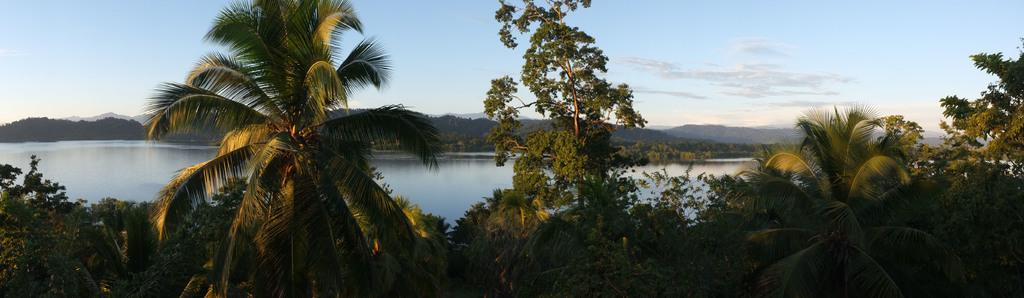What type of vegetation is at the bottom of the image? There are trees at the bottom of the image. What natural feature is visible in the image? There is a surface of water in the image. What geographical feature is located in the middle of the image? There are mountains in the middle of the image. What is visible at the top of the image? There is a sky at the top of the image. How many bikes are parked on the surface of water in the image? There are no bikes present in the image; it features trees, water, mountains, and sky. Can you see a nail sticking out of the mountain in the image? There is no nail visible in the image; it only contains trees, water, mountains, and sky. 